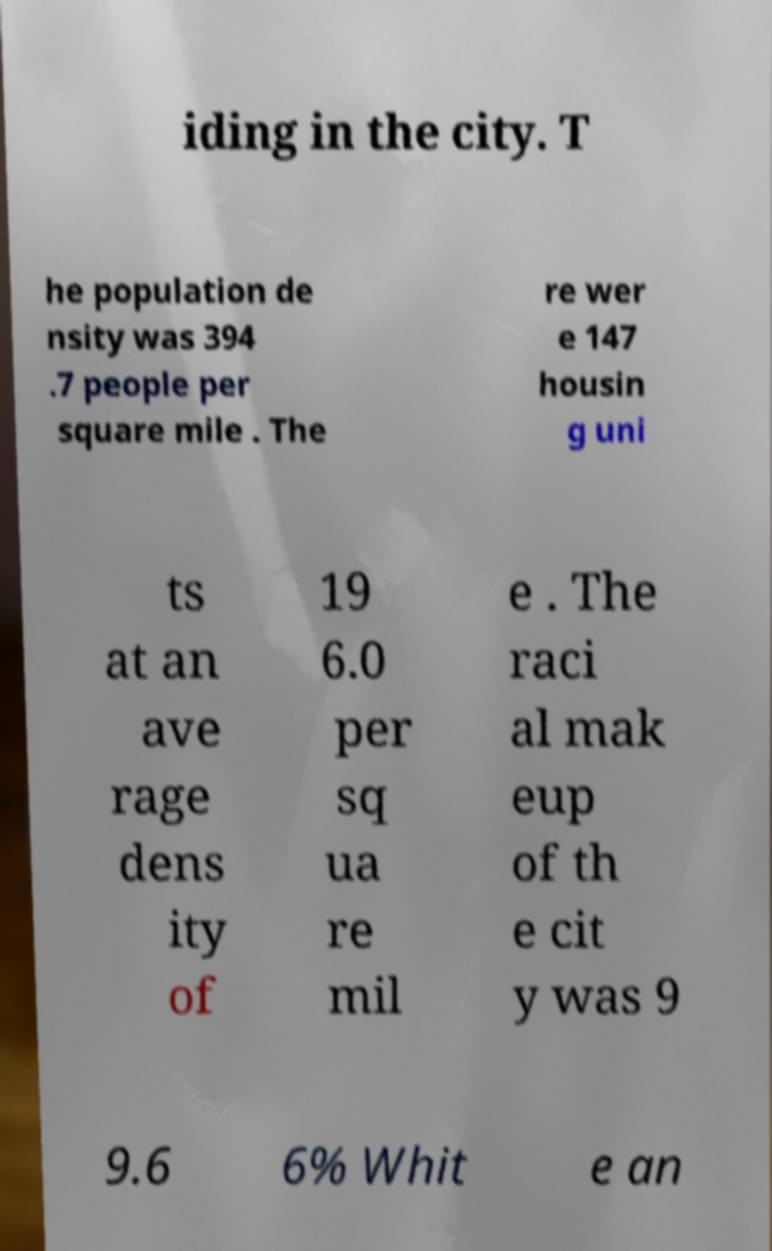Could you extract and type out the text from this image? iding in the city. T he population de nsity was 394 .7 people per square mile . The re wer e 147 housin g uni ts at an ave rage dens ity of 19 6.0 per sq ua re mil e . The raci al mak eup of th e cit y was 9 9.6 6% Whit e an 